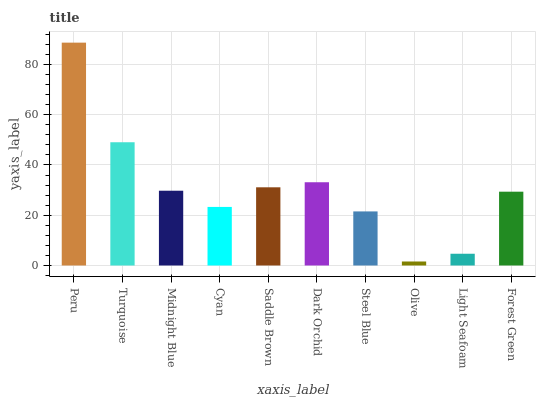Is Olive the minimum?
Answer yes or no. Yes. Is Peru the maximum?
Answer yes or no. Yes. Is Turquoise the minimum?
Answer yes or no. No. Is Turquoise the maximum?
Answer yes or no. No. Is Peru greater than Turquoise?
Answer yes or no. Yes. Is Turquoise less than Peru?
Answer yes or no. Yes. Is Turquoise greater than Peru?
Answer yes or no. No. Is Peru less than Turquoise?
Answer yes or no. No. Is Midnight Blue the high median?
Answer yes or no. Yes. Is Forest Green the low median?
Answer yes or no. Yes. Is Forest Green the high median?
Answer yes or no. No. Is Peru the low median?
Answer yes or no. No. 